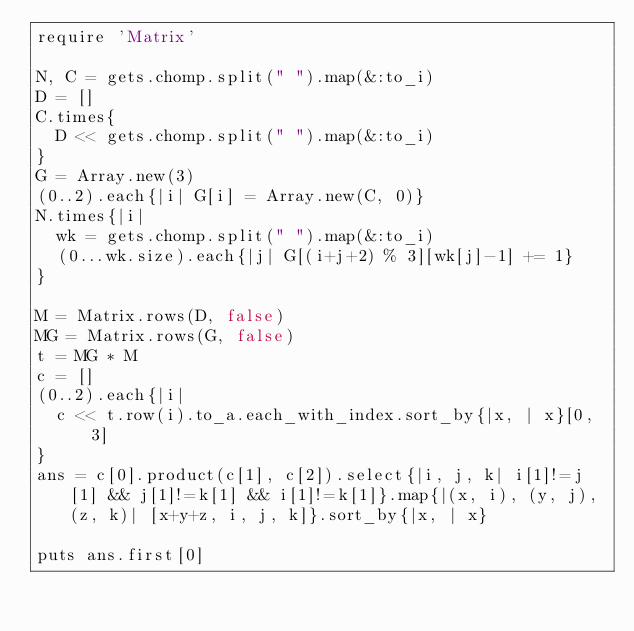Convert code to text. <code><loc_0><loc_0><loc_500><loc_500><_Ruby_>require 'Matrix'

N, C = gets.chomp.split(" ").map(&:to_i)
D = []
C.times{
  D << gets.chomp.split(" ").map(&:to_i)
}
G = Array.new(3)
(0..2).each{|i| G[i] = Array.new(C, 0)}
N.times{|i|
  wk = gets.chomp.split(" ").map(&:to_i)
  (0...wk.size).each{|j| G[(i+j+2) % 3][wk[j]-1] += 1}
}

M = Matrix.rows(D, false)
MG = Matrix.rows(G, false)
t = MG * M
c = []
(0..2).each{|i|
  c << t.row(i).to_a.each_with_index.sort_by{|x, | x}[0, 3]
}
ans = c[0].product(c[1], c[2]).select{|i, j, k| i[1]!=j[1] && j[1]!=k[1] && i[1]!=k[1]}.map{|(x, i), (y, j), (z, k)| [x+y+z, i, j, k]}.sort_by{|x, | x}

puts ans.first[0]
</code> 